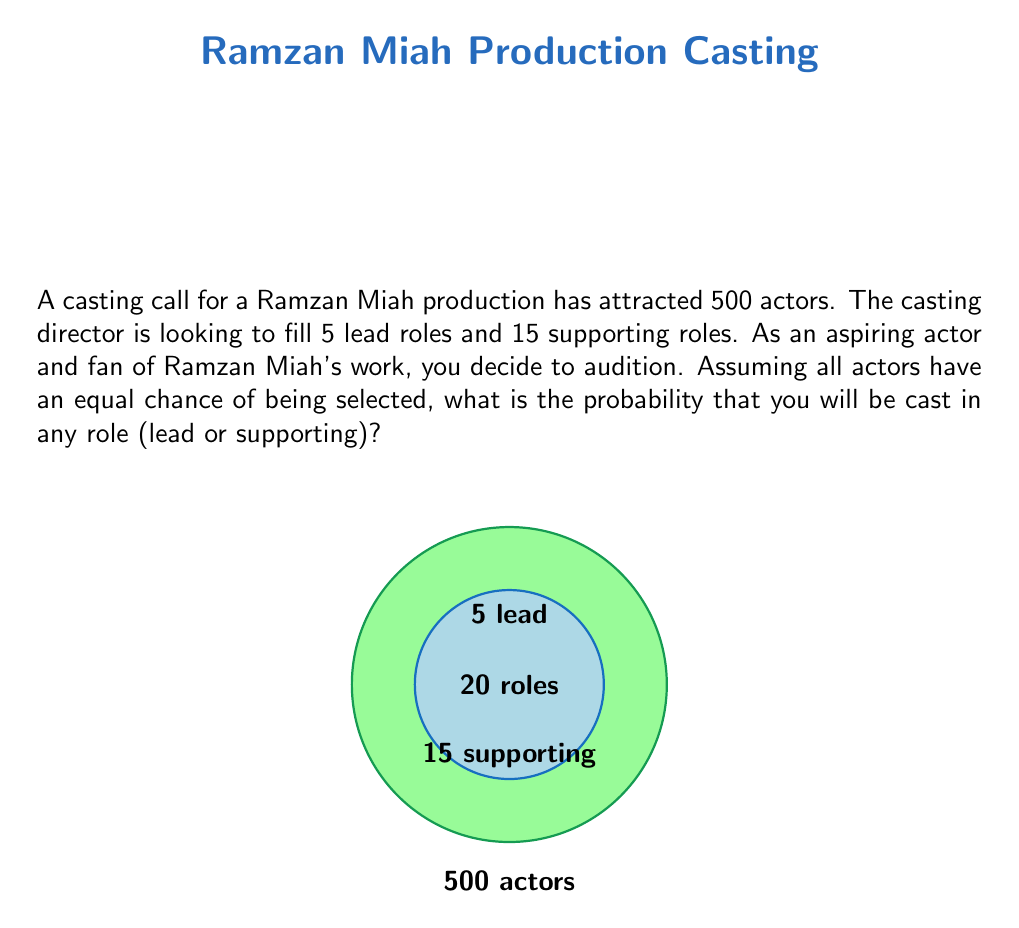Help me with this question. Let's approach this step-by-step:

1) First, we need to calculate the total number of roles available:
   Lead roles + Supporting roles = $5 + 15 = 20$ total roles

2) The probability of being cast in any role is the number of favorable outcomes (getting a role) divided by the total number of possible outcomes (total number of actors):

   $P(\text{getting a role}) = \frac{\text{number of roles}}{\text{total number of actors}}$

3) Substituting the values:

   $P(\text{getting a role}) = \frac{20}{500}$

4) Simplify the fraction:

   $P(\text{getting a role}) = \frac{1}{25} = 0.04$

5) To express this as a percentage:

   $0.04 \times 100\% = 4\%$

Therefore, the probability of being cast in any role (lead or supporting) is $\frac{1}{25}$ or 4%.
Answer: $\frac{1}{25}$ or 4% 